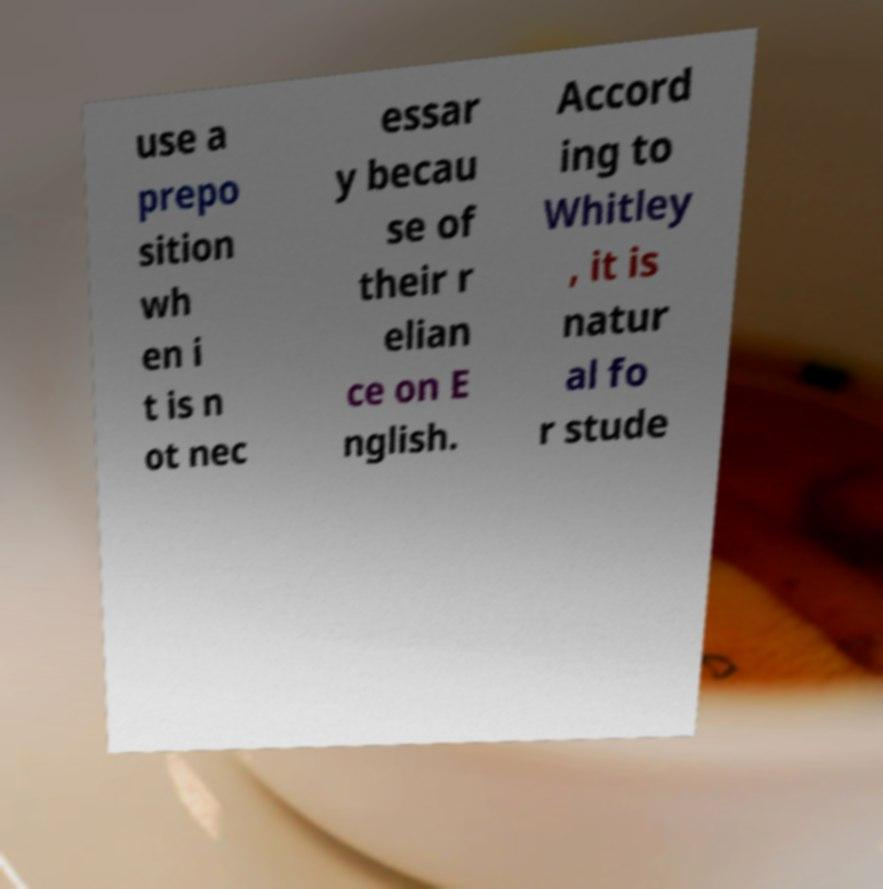Please read and relay the text visible in this image. What does it say? use a prepo sition wh en i t is n ot nec essar y becau se of their r elian ce on E nglish. Accord ing to Whitley , it is natur al fo r stude 